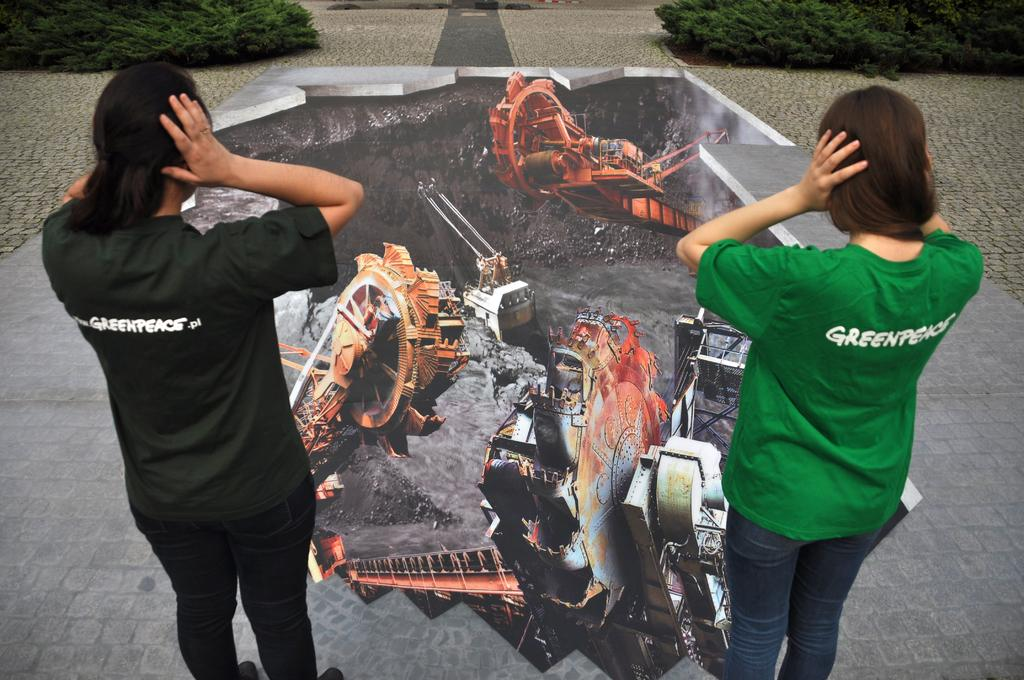Provide a one-sentence caption for the provided image. Two women wearing shirts that have Greenpeace on the back. 